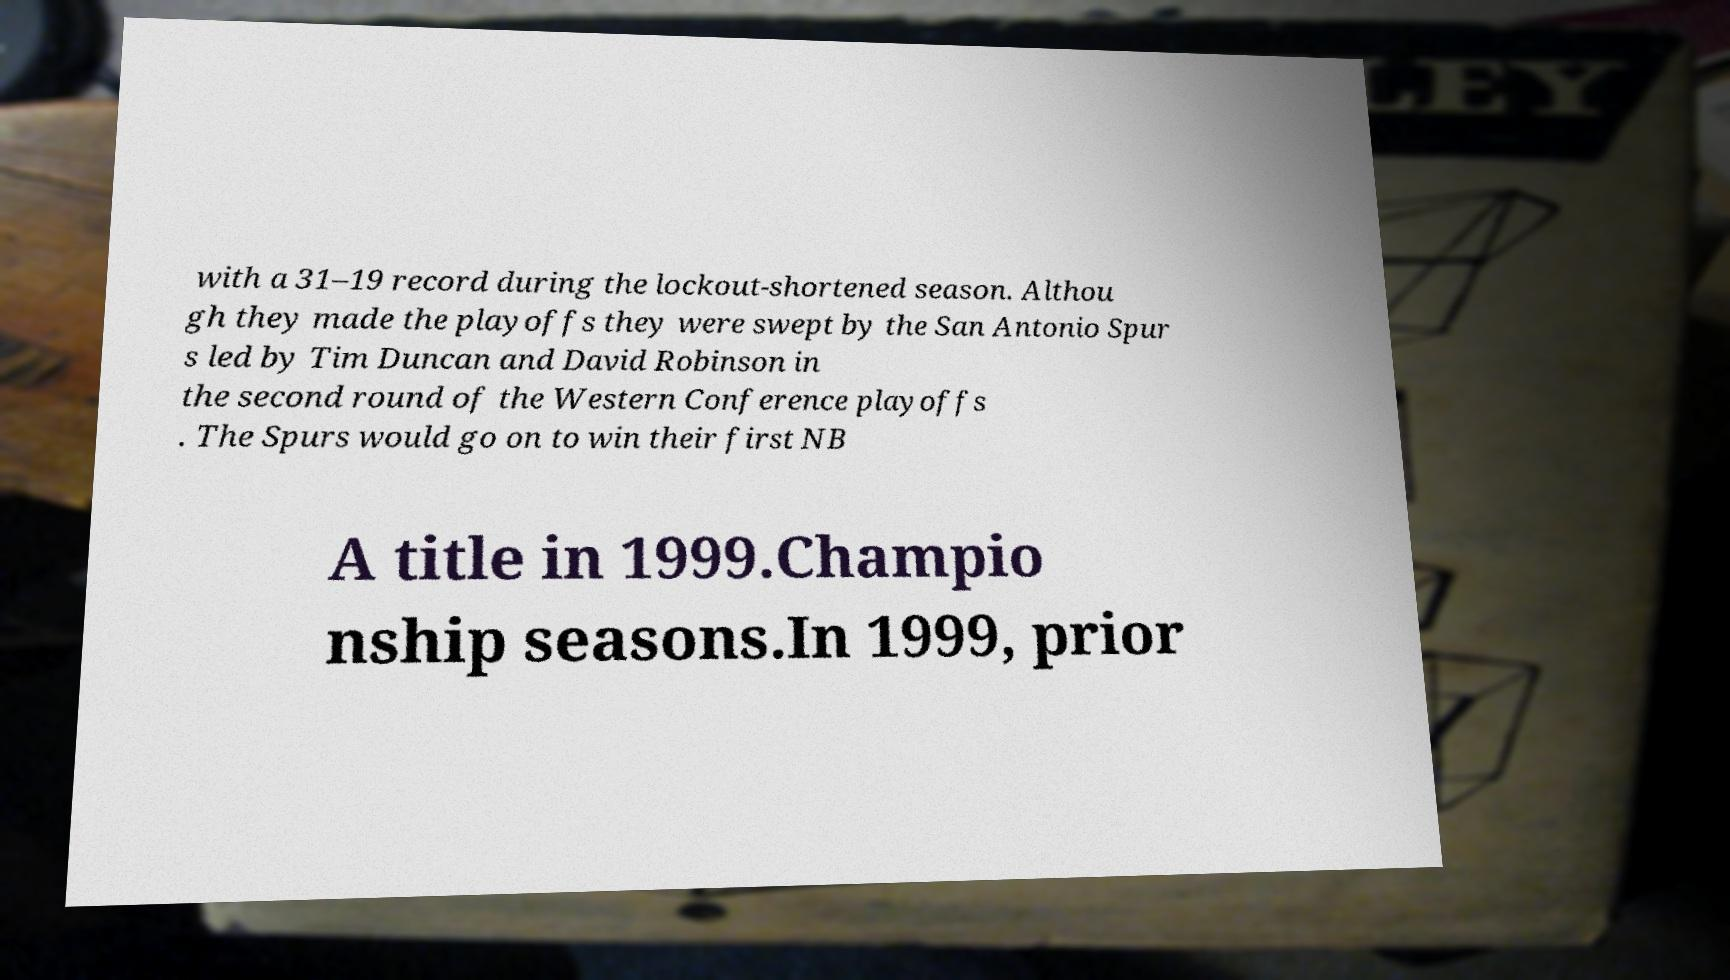Can you accurately transcribe the text from the provided image for me? with a 31–19 record during the lockout-shortened season. Althou gh they made the playoffs they were swept by the San Antonio Spur s led by Tim Duncan and David Robinson in the second round of the Western Conference playoffs . The Spurs would go on to win their first NB A title in 1999.Champio nship seasons.In 1999, prior 